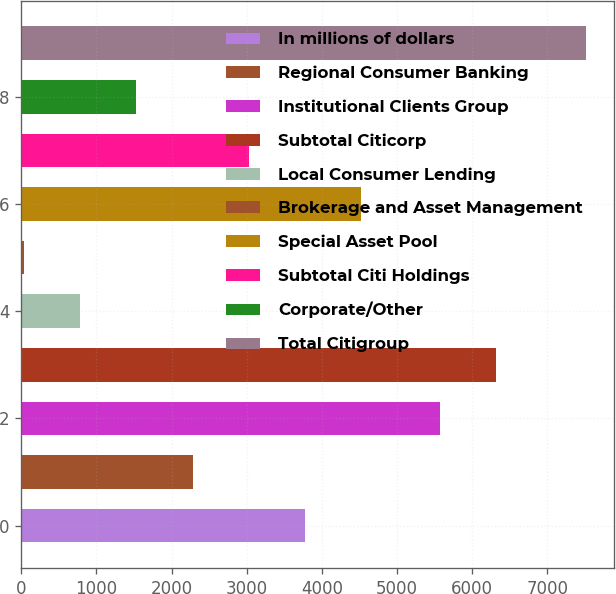<chart> <loc_0><loc_0><loc_500><loc_500><bar_chart><fcel>In millions of dollars<fcel>Regional Consumer Banking<fcel>Institutional Clients Group<fcel>Subtotal Citicorp<fcel>Local Consumer Lending<fcel>Brokerage and Asset Management<fcel>Special Asset Pool<fcel>Subtotal Citi Holdings<fcel>Corporate/Other<fcel>Total Citigroup<nl><fcel>3777<fcel>2281<fcel>5567<fcel>6315<fcel>785<fcel>37<fcel>4525<fcel>3029<fcel>1533<fcel>7517<nl></chart> 